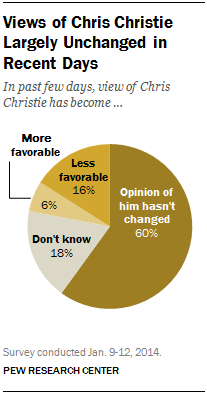Give some essential details in this illustration. The two largest segments differ by 42. The color of the 'Don't Know' segment is gray. 